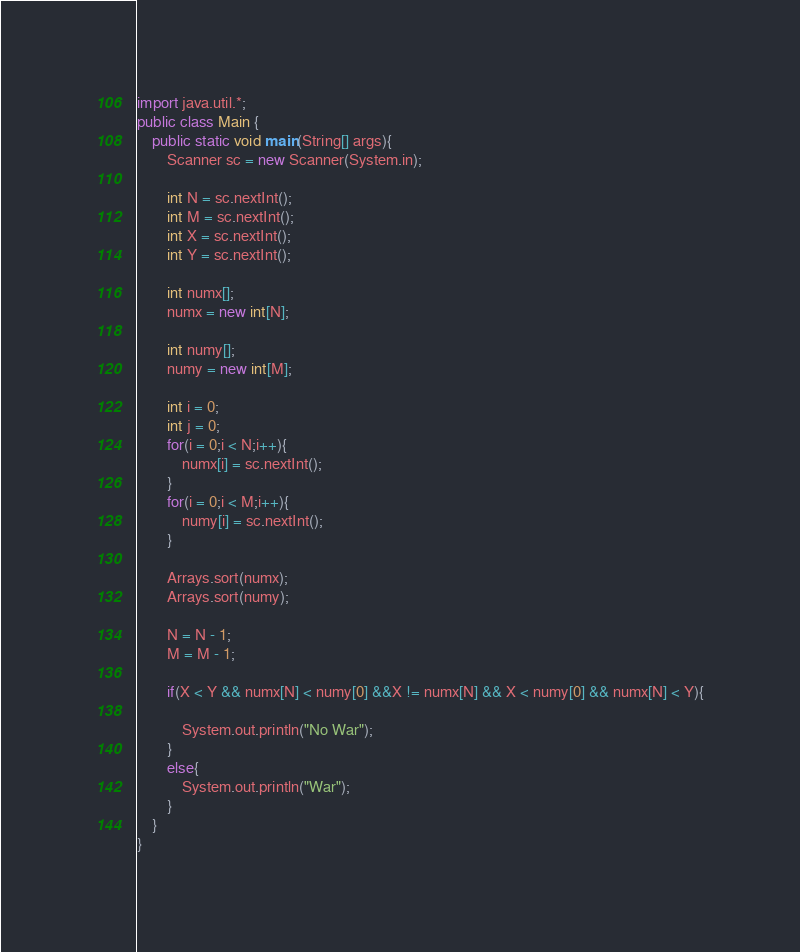Convert code to text. <code><loc_0><loc_0><loc_500><loc_500><_Java_>import java.util.*;
public class Main {
	public static void main(String[] args){
		Scanner sc = new Scanner(System.in);
		
		int N = sc.nextInt();
		int M = sc.nextInt();
		int X = sc.nextInt();
		int Y = sc.nextInt();
		
		int numx[];
		numx = new int[N];
		
		int numy[];
		numy = new int[M];
		
		int i = 0;
		int j = 0;
		for(i = 0;i < N;i++){
			numx[i] = sc.nextInt();
		}
		for(i = 0;i < M;i++){
			numy[i] = sc.nextInt();
		}
		
		Arrays.sort(numx);
		Arrays.sort(numy);
		
		N = N - 1;
		M = M - 1;
		
		if(X < Y && numx[N] < numy[0] &&X != numx[N] && X < numy[0] && numx[N] < Y){
			
			System.out.println("No War");
		}
		else{
			System.out.println("War");
		}
	}
}</code> 